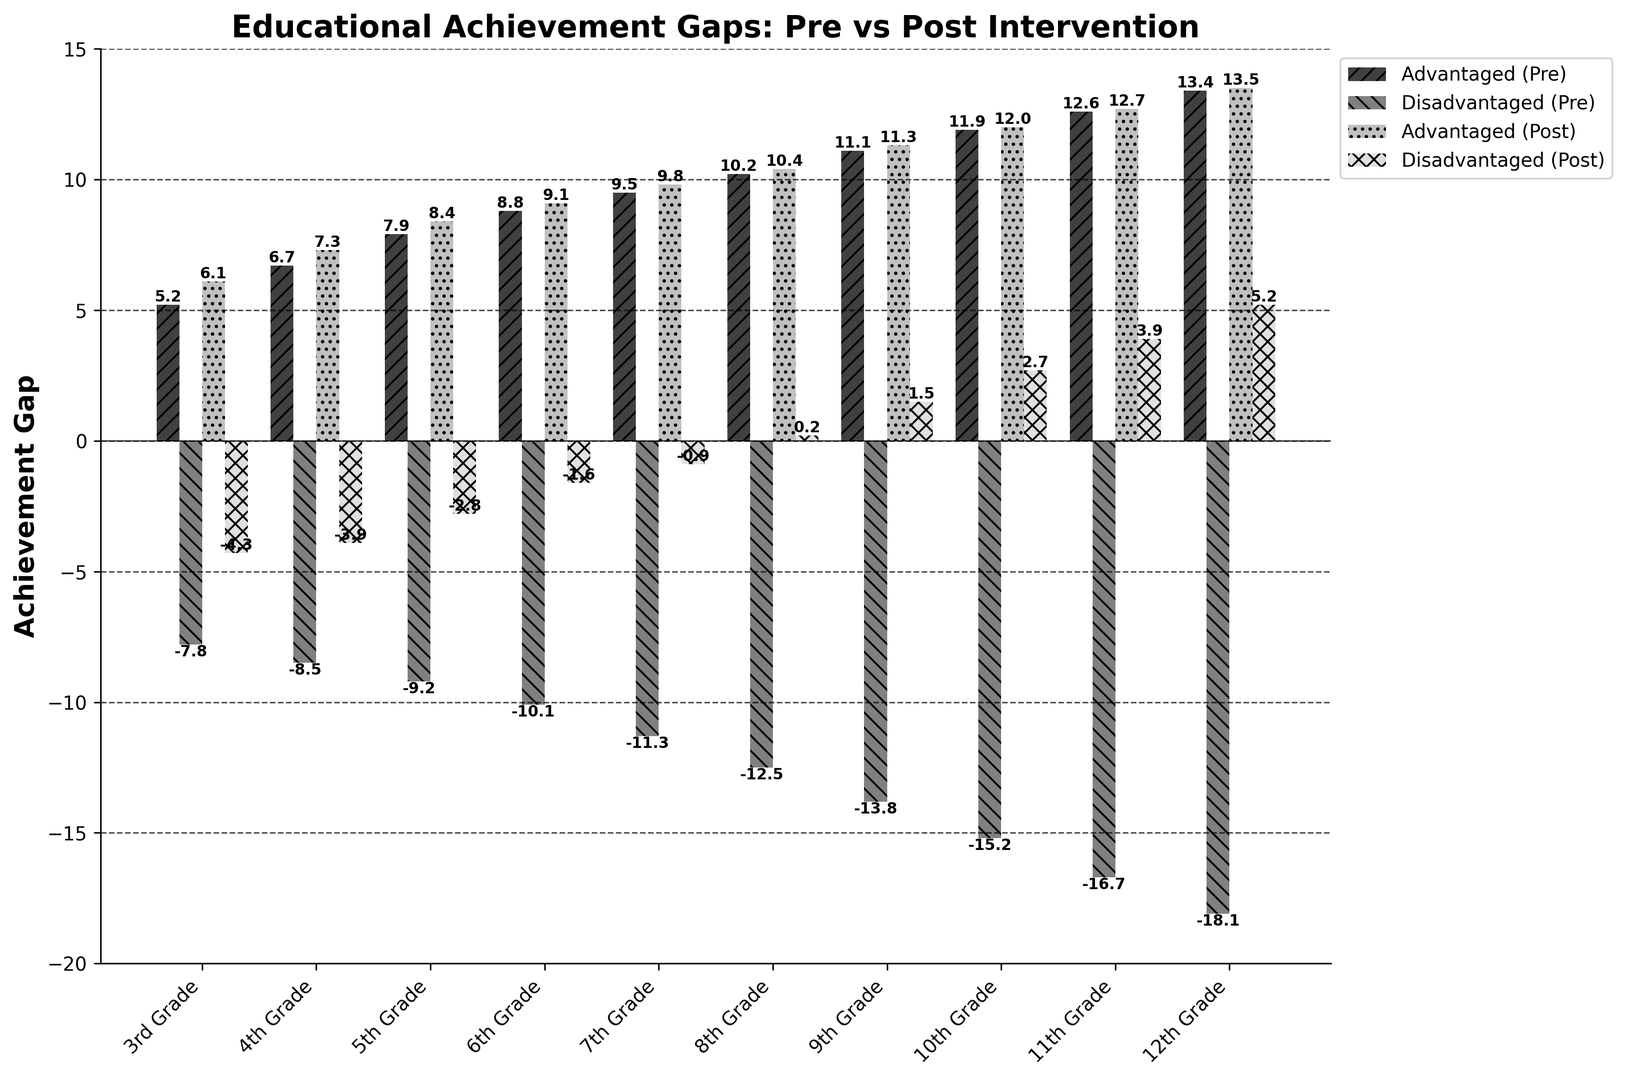What is the difference in achievement gaps for Disadvantaged Students between Pre- and Post-Intervention for 8th Grade? For 8th Grade, the achievement gap for Disadvantaged Students Pre-Intervention is -12.5 and Post-Intervention is 0.2. The difference is calculated as Post-Intervention value minus Pre-Intervention value: 0.2 - (-12.5) = 12.7
Answer: 12.7 Which grade level showed the highest improvement in the achievement gap for Disadvantaged Students? By examining the improvements, we see the highest improvement in achievement gap for Disadvantaged Students occurred in 12th Grade, where the achievement gap improved from -18.1 to 5.2, a change of 5.2 - (-18.1) = 23.3
Answer: 12th Grade Compare the achievement gap for Advantaged Students in 3rd Grade and 7th Grade, Post-Intervention. Which one is higher? For 3rd Grade, the Post-Intervention achievement gap for Advantaged Students is 6.1, and for 7th Grade, it is 9.8. Since 9.8 is greater than 6.1, the 7th Grade achievement gap is higher.
Answer: 7th Grade What’s the average achievement gap for Advantaged Students across all grade levels Post-Intervention? To calculate the average, sum all the Post-Intervention scores for Advantaged Students and divide by the number of grade levels: (6.1 + 7.3 + 8.4 + 9.1 + 9.8 + 10.4 + 11.3 + 12.0 + 12.7 + 13.5) / 10 = 100.6 / 10 = 10.06
Answer: 10.06 Compare the achievement gaps for Disadvantaged Students in Pre-Intervention and Post-Intervention for 5th and 10th Grade. Which grade level showed a greater reduction? For 5th Grade, the gap improved from -9.2 to -2.8, an improvement of -2.8 - (-9.2) = 6.4. For 10th Grade, the gap improved from -15.2 to 2.7, an improvement of 2.7 - (-15.2) = 17.9. Therefore, 10th Grade showed a greater reduction.
Answer: 10th Grade Which group had the tallest bar in the figure and in which grade? The tallest bar in the figure corresponds to the Advantaged Students Post-Intervention for 12th Grade with an achievement gap of 13.5
Answer: Advantaged (Post) in 12th Grade How does the achievement gap for Advantaged Students in 12th Grade Pre-Intervention compare to Disadvantaged Students in 9th Grade Pre-Intervention? For 12th Grade Advantaged Students Pre-Intervention, the gap is 13.4. For 9th Grade Disadvantaged Students Pre-Intervention, the gap is -13.8. 13.4 is greater than -13.8, showing a significant difference.
Answer: 12th Grade Advantaged is greater What’s the combined post-intervention achievement gap for Advantaged Students in 5th and 7th Grade? Add the Post-Intervention achievement gaps for 5th and 7th Grade Advantaged Students: 8.4 + 9.8 = 18.2
Answer: 18.2 Identify the grade level where the Disadvantaged Students reached a positive achievement gap Post-Intervention. Observing the Post-Intervention values, Disadvantaged Students reached a positive achievement gap for grades 8th through 12th, starting at 0.2 in 8th Grade and higher in subsequent grades.
Answer: 8th Grade 